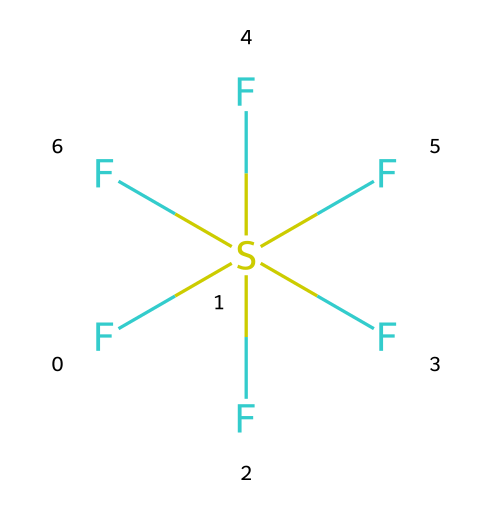What is the name of this chemical? The chemical structure shown is sulfur hexafluoride, derived from its formula SF6, where sulfur is bonded to six fluorine atoms.
Answer: sulfur hexafluoride How many fluorine atoms are present in this compound? The SMILES representation shows six 'F' atoms connected to the sulfur atom, indicating that there are six fluorine atoms.
Answer: six Is sulfur hexafluoride a polar molecule? Due to the symmetrical arrangement of the fluorine atoms around the sulfur atom, the dipole moments cancel each other out, making the molecule nonpolar.
Answer: no What type of bonding is present in sulfur hexafluoride? The structure indicates that sulfur forms six single covalent bonds with each fluorine atom, which is typical for this hypervalent compound.
Answer: covalent bonds How many total atoms are in sulfur hexafluoride? The formula consists of one sulfur atom and six fluorine atoms, leading to a total of seven atoms in the molecule.
Answer: seven What is the hybridization of the sulfur atom in this compound? The sulfur atom is surrounded by six fluorine atoms, which requires sp³d² hybridization to accommodate the six bonded pairs of electrons in a octahedral geometry.
Answer: sp³d² Is sulfur hexafluoride considered a hypervalent compound? Yes, sulfur hexafluoride has a central sulfur atom that exceeds the octet rule by having more than eight electrons around it, thus classifying it as hypervalent.
Answer: yes 